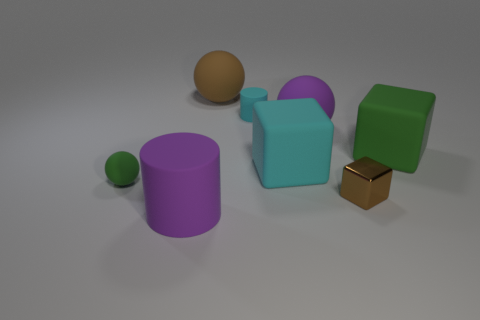Are there any yellow metal things that have the same size as the cyan rubber block?
Provide a short and direct response. No. Is the color of the large rubber thing that is behind the cyan cylinder the same as the small matte sphere?
Give a very brief answer. No. The object that is to the right of the purple matte sphere and behind the tiny green matte object is what color?
Provide a succinct answer. Green. The brown object that is the same size as the green sphere is what shape?
Your answer should be compact. Cube. Is there a tiny blue matte object of the same shape as the small green rubber thing?
Make the answer very short. No. There is a purple matte object right of the brown rubber object; is it the same size as the large green rubber thing?
Your answer should be compact. Yes. What size is the thing that is in front of the small rubber sphere and to the left of the metal object?
Provide a short and direct response. Large. What number of other objects are the same material as the big brown sphere?
Keep it short and to the point. 6. There is a cyan thing in front of the cyan matte cylinder; what size is it?
Keep it short and to the point. Large. Does the large cylinder have the same color as the tiny cylinder?
Your answer should be compact. No. 